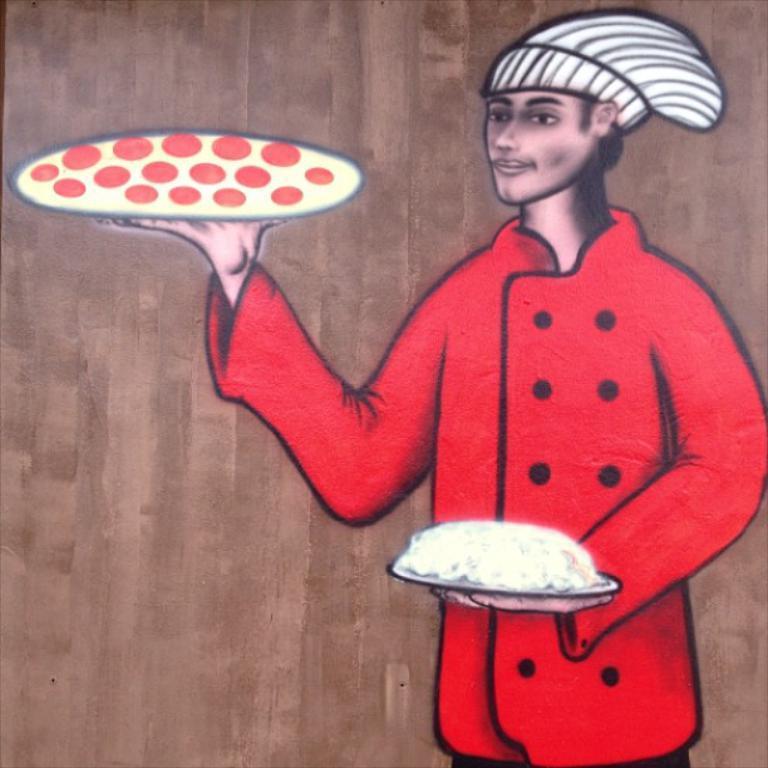Please provide a concise description of this image. In this image I can see the painting of the person on the brown color surface. I can see the person is wearing the red color dress and holding the plates with food. 